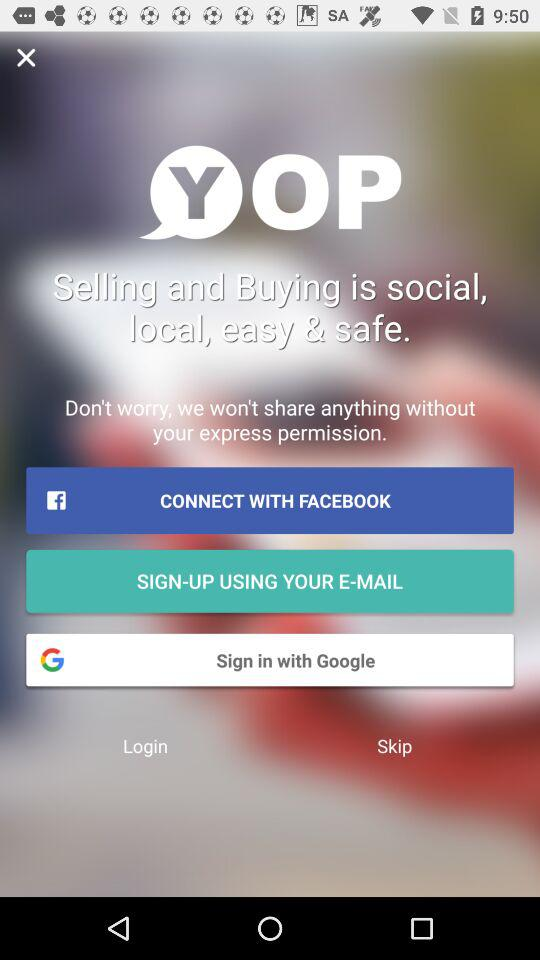What is the name of the application? The name of the application is "YOP". 